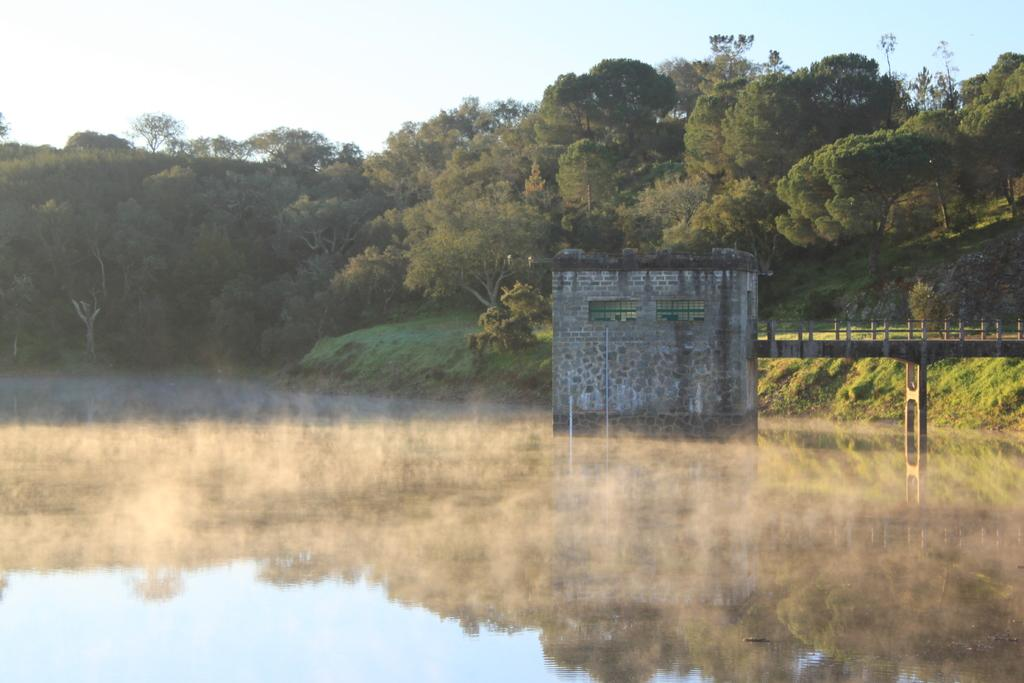What type of structure can be seen in the image? There is a bridge in the image. What other man-made structure is visible in the image? There is a building in the image. What natural element is present in the image? There is water visible in the image. What type of vegetation can be seen in the image? There are trees in the image. What part of the natural environment is visible in the image? The sky is visible in the image. Can you describe the weather conditions in the image? Clouds are present in the sky, suggesting that it might be partly cloudy. How many thumbs can be seen on the bridge in the image? There are no thumbs visible in the image, as it features a bridge, a building, water, trees, and the sky. What type of sea creature is swimming in the water in the image? There is no sea or sea creature present in the image; it features a bridge, a building, water, trees, and the sky. 